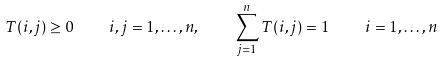Convert formula to latex. <formula><loc_0><loc_0><loc_500><loc_500>T ( i , j ) \geq 0 \quad i , j = 1 , \dots , n , \quad \sum _ { j = 1 } ^ { n } T ( i , j ) = 1 \quad i = 1 , \dots , n</formula> 